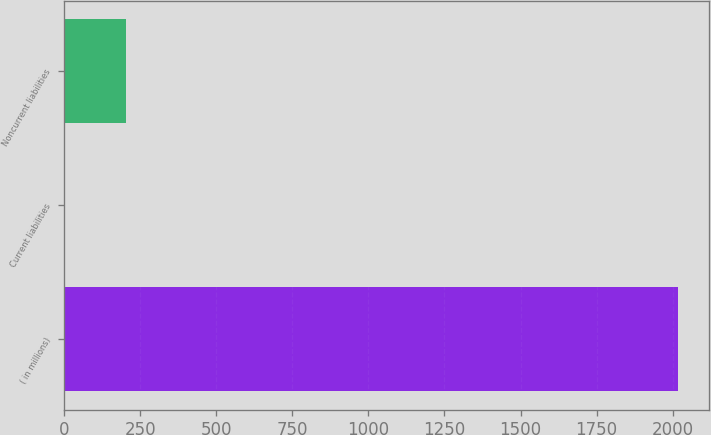<chart> <loc_0><loc_0><loc_500><loc_500><bar_chart><fcel>( in millions)<fcel>Current liabilities<fcel>Noncurrent liabilities<nl><fcel>2018<fcel>0.7<fcel>202.43<nl></chart> 